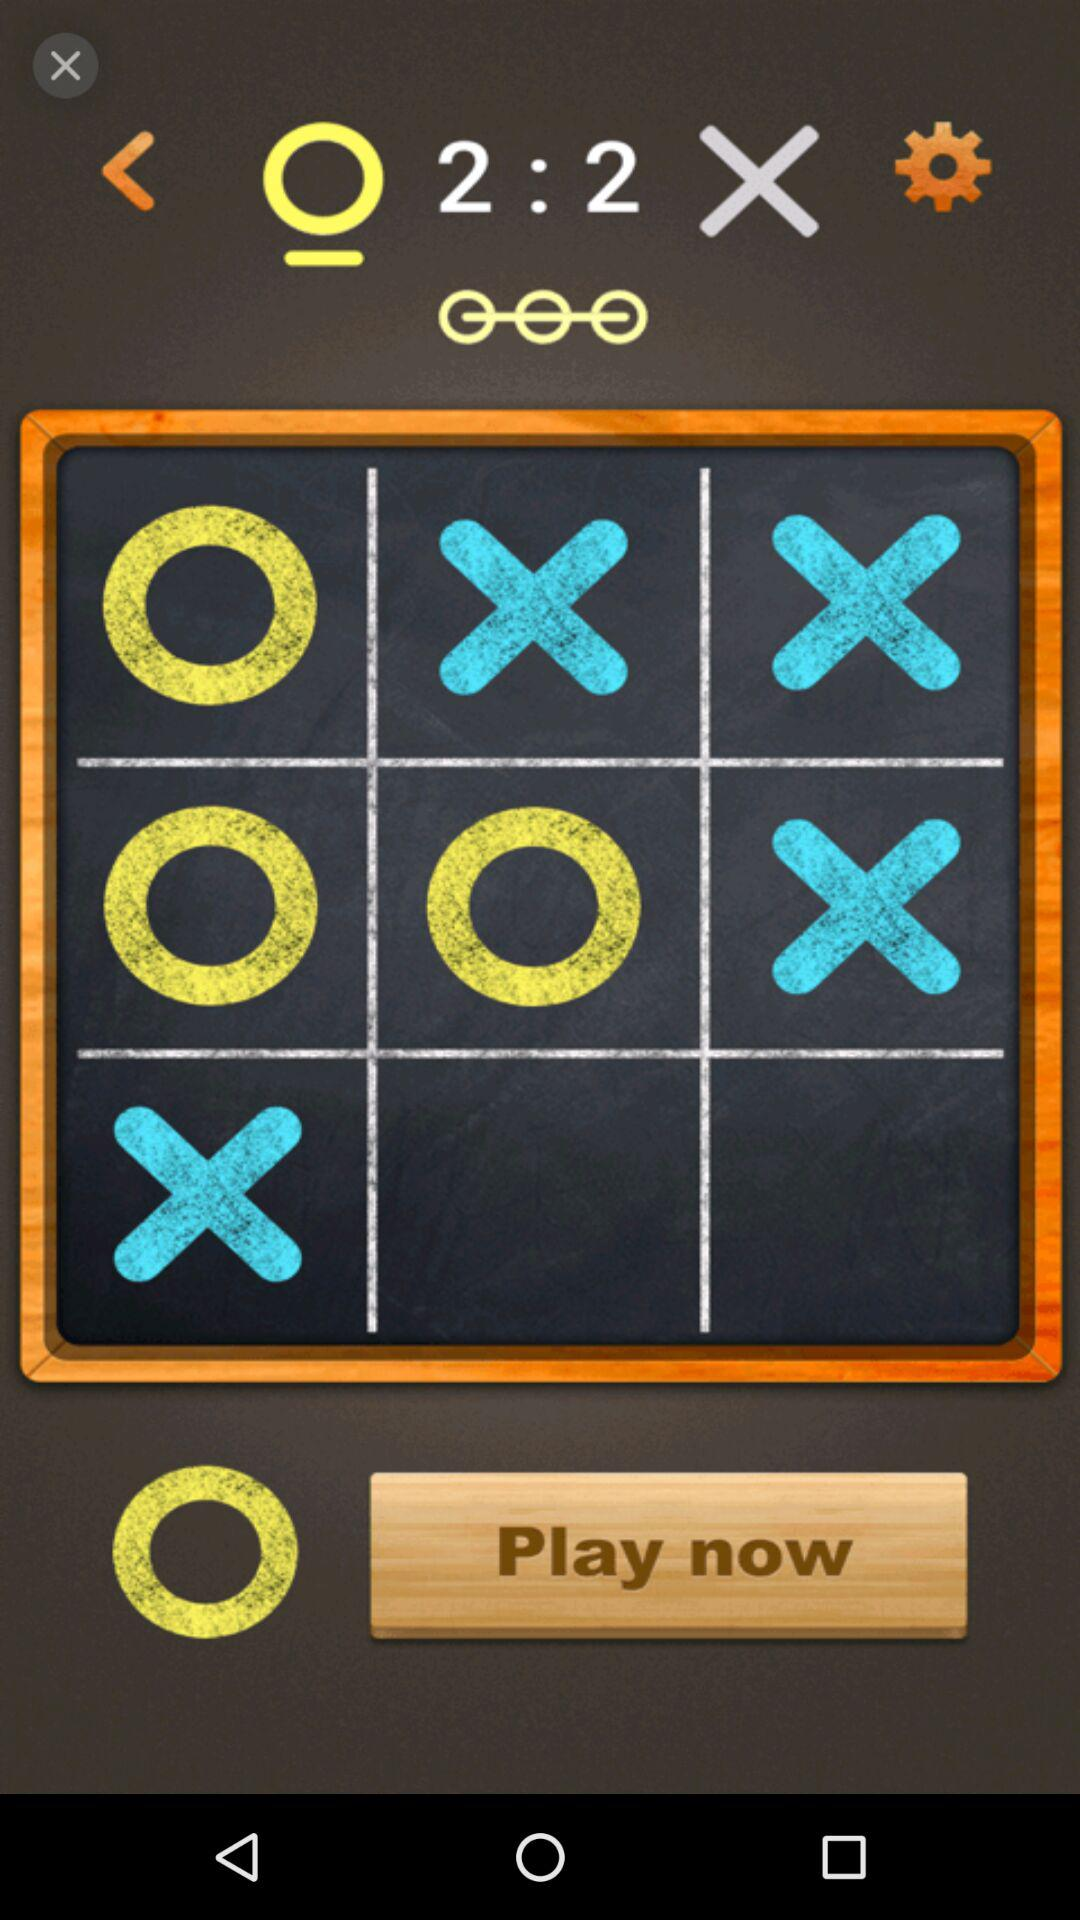What is the sum of the numbers in the text?
Answer the question using a single word or phrase. 4 